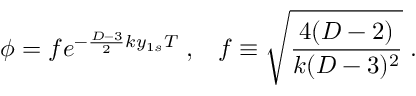Convert formula to latex. <formula><loc_0><loc_0><loc_500><loc_500>\phi = f e ^ { - \frac { D - 3 } { 2 } k y _ { 1 s } T } \, , \, f \equiv \sqrt { \frac { 4 ( D - 2 ) } { k ( D - 3 ) ^ { 2 } } } \, .</formula> 